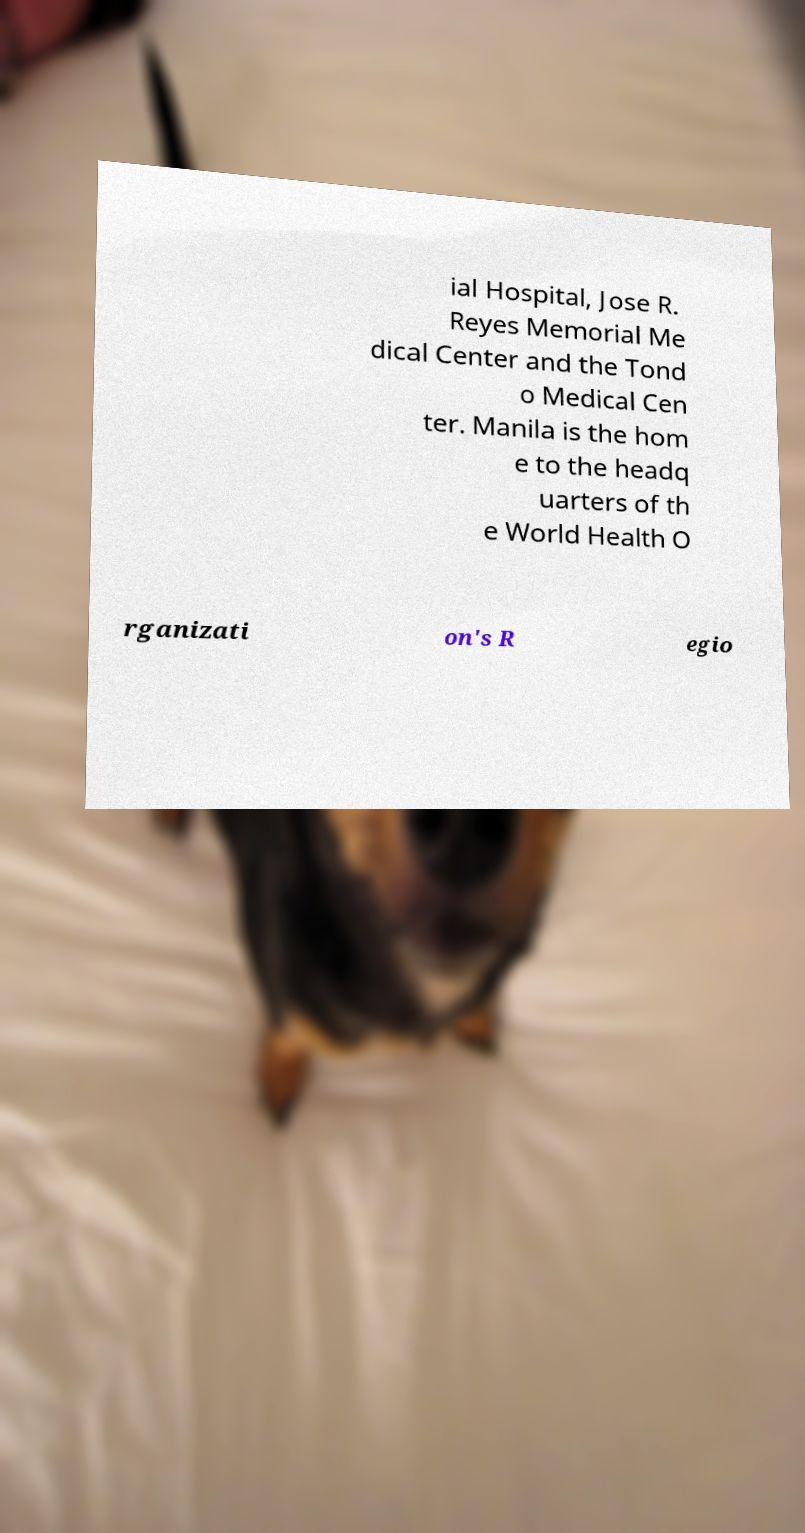Can you read and provide the text displayed in the image?This photo seems to have some interesting text. Can you extract and type it out for me? ial Hospital, Jose R. Reyes Memorial Me dical Center and the Tond o Medical Cen ter. Manila is the hom e to the headq uarters of th e World Health O rganizati on's R egio 